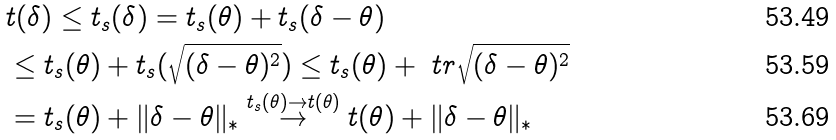<formula> <loc_0><loc_0><loc_500><loc_500>& t ( \delta ) \leq t _ { s } ( \delta ) = t _ { s } ( \theta ) + t _ { s } ( \delta - \theta ) \\ & \leq t _ { s } ( \theta ) + t _ { s } ( \sqrt { ( \delta - \theta ) ^ { 2 } } ) \leq t _ { s } ( \theta ) + \ t r \sqrt { ( \delta - \theta ) ^ { 2 } } \\ & = t _ { s } ( \theta ) + \| \delta - \theta \| _ { * } \overset { t _ { s } ( \theta ) \rightarrow t ( \theta ) } { \rightarrow } t ( \theta ) + \| \delta - \theta \| _ { * }</formula> 